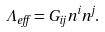Convert formula to latex. <formula><loc_0><loc_0><loc_500><loc_500>\label l { L e f f } \Lambda _ { e f f } = G _ { i j } n ^ { i } n ^ { j } .</formula> 